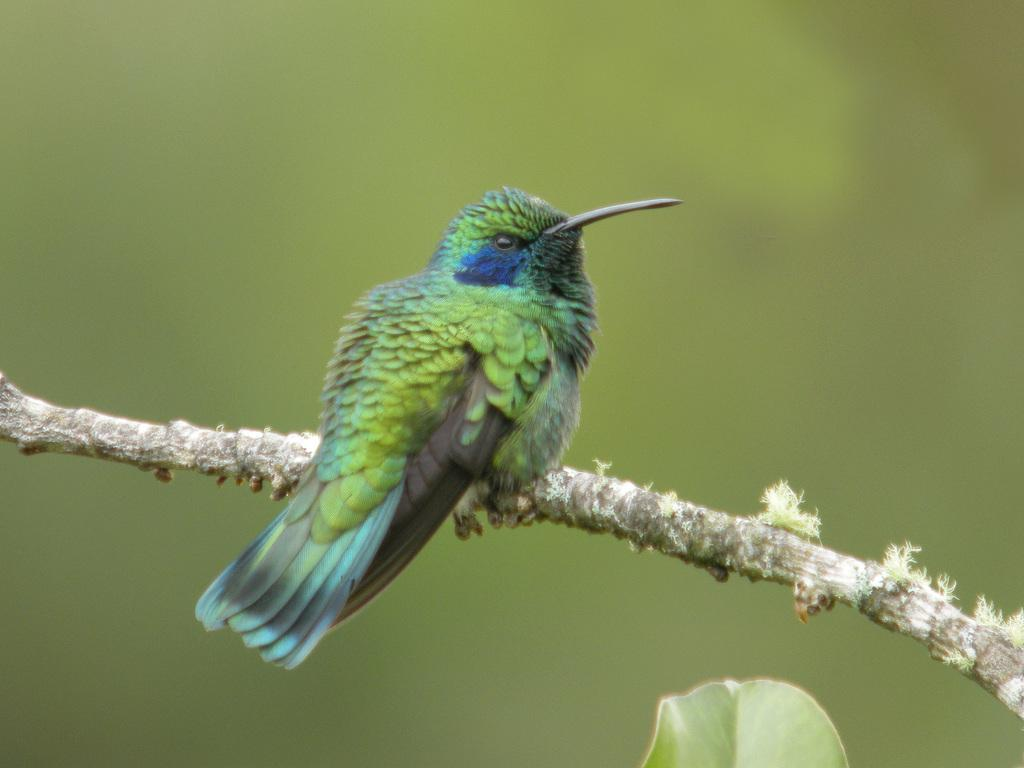What type of animal is in the image? There is a bird in the image. Where is the bird located? The bird is on a stem. What can be observed about the background of the image? The background of the image is blurred. What is present at the bottom of the image? There is a leaf at the bottom of the image. What is the chance of the bird flipping a pancake in the image? There is no pancake present in the image, so the bird cannot flip a pancake. 